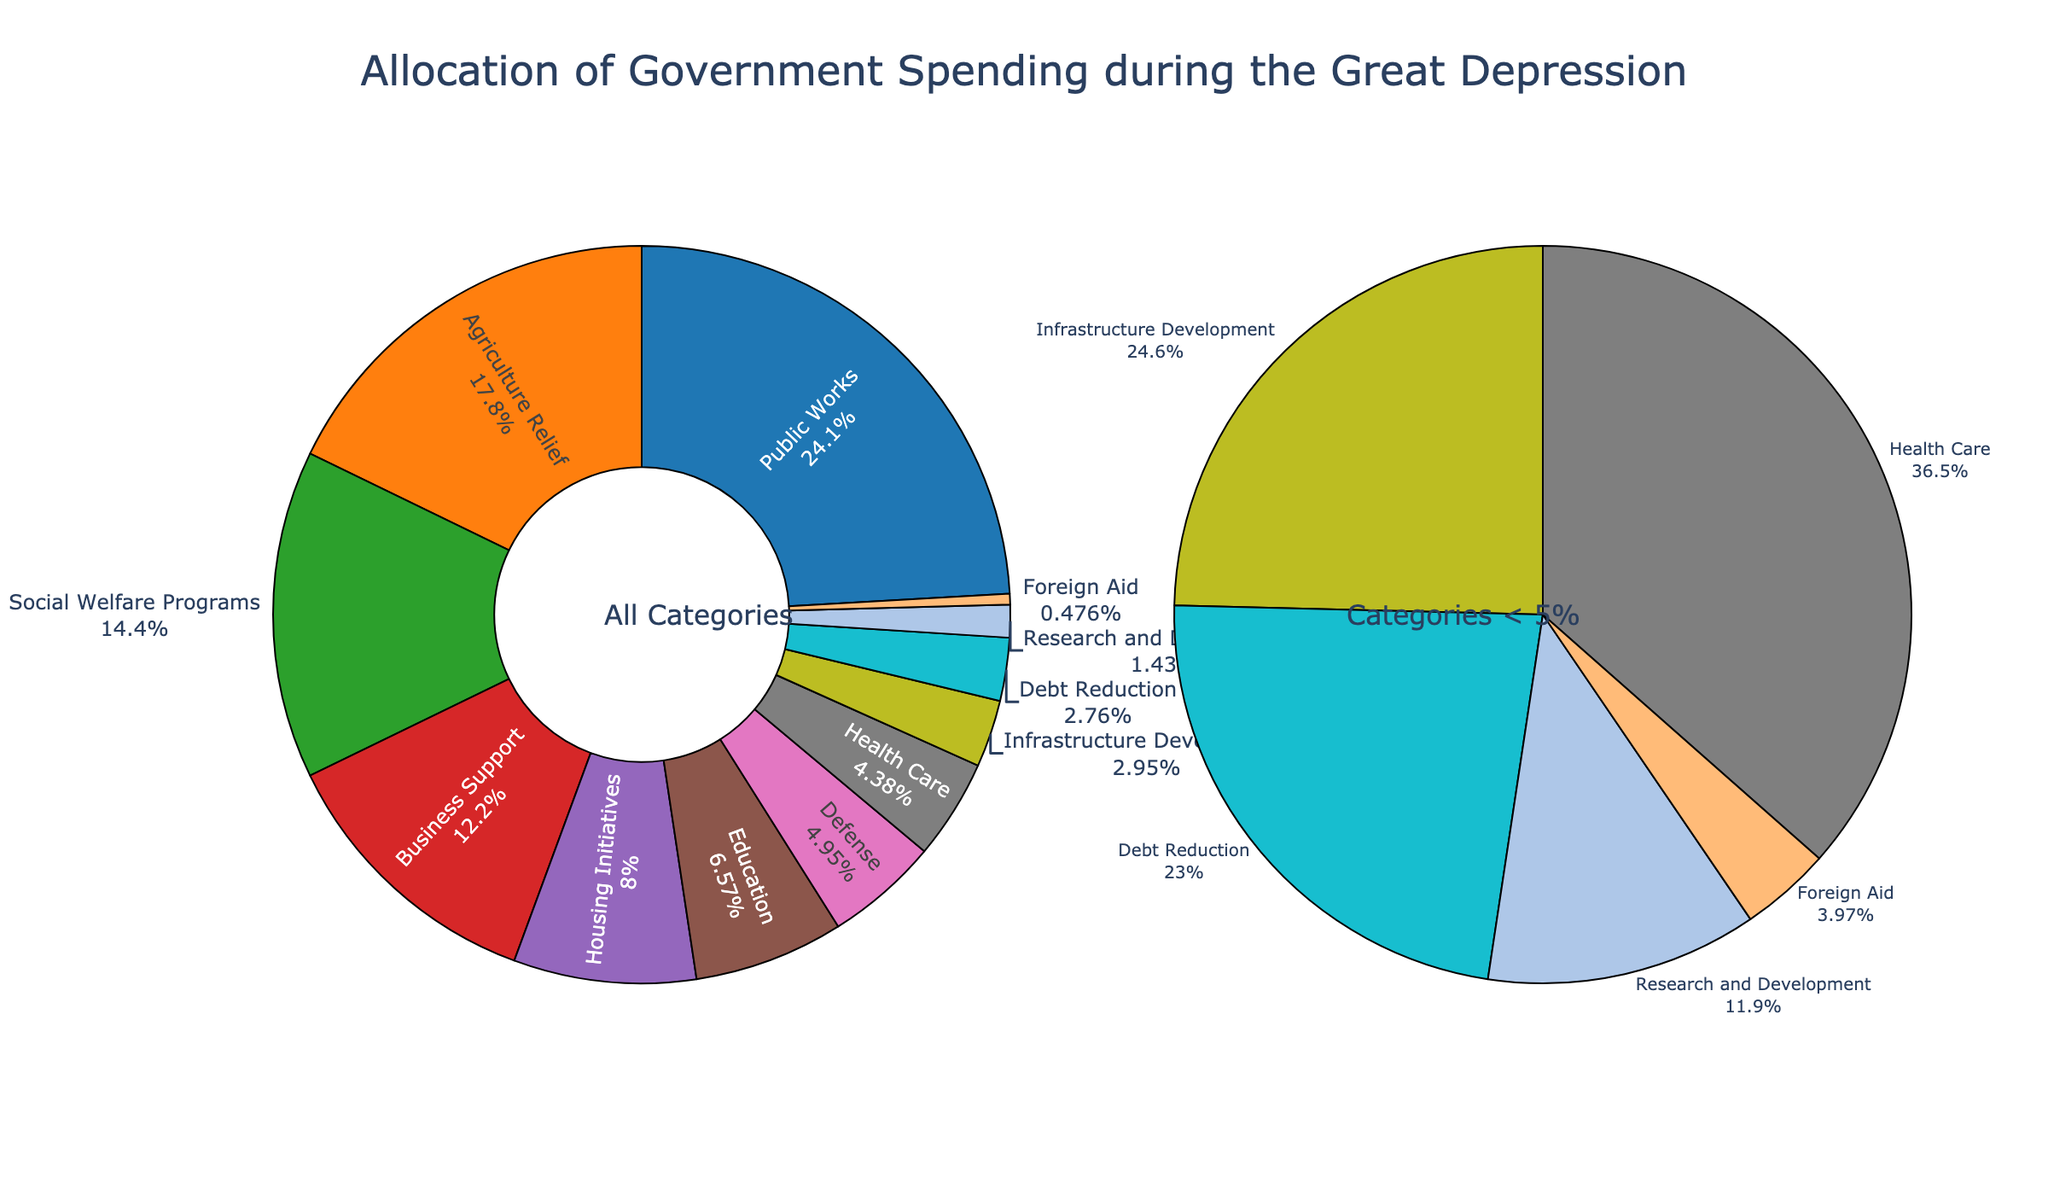What are the top three categories in terms of allocation percentage? By inspecting the main pie chart, the top three categories with the largest slices are "Public Works", "Agriculture Relief", and "Social Welfare Programs". Their respective percentages in the pie chart are 25.3%, 18.7%, and 15.1%.
Answer: Public Works, Agriculture Relief, Social Welfare Programs How much more is allocated to Public Works compared to Defense? By referring to the labels, Public Works has 25.3% while Defense has 5.2%. The difference can be calculated by subtracting the smaller percentage from the larger one: 25.3% - 5.2% = 20.1%.
Answer: 20.1% Which category has the smallest allocation and what is its percentage? By looking at the main pie chart and identifying the smallest slice or referring to the smaller pie chart for categories less than 5%, the "Foreign Aid" slice is the smallest with 0.5% allocation.
Answer: Foreign Aid, 0.5% Is the sum of allocations for Social Welfare Programs and Business Support greater than Agriculture Relief? By looking at their respective percentages in the pie chart: Social Welfare Programs (15.1%) + Business Support (12.8%) = 27.9%, while Agriculture Relief is 18.7%. Since 27.9% > 18.7%, the sum is indeed greater.
Answer: Yes Which categories have an allocation under 5%? By inspecting the smaller pie chart dedicated to categories under 5%, we see the categories labeled "Defense", "Health Care", "Infrastructure Development", "Debt Reduction", "Research and Development", and "Foreign Aid". Their respective percentages help us confirm they are all under 5%.
Answer: Defense, Health Care, Infrastructure Development, Debt Reduction, Research and Development, Foreign Aid What's the total percentage of spending on Defense, Health Care, and Infrastructure Development combined? According to the visual representation, Defense is 5.2%, Health Care is 4.6%, and Infrastructure Development is 3.1%. Adding these up: 5.2% + 4.6% + 3.1% = 12.9%.
Answer: 12.9% How does the allocation for Housing Initiatives compare to Education in terms of percentage points? Referring to their pie chart labels, Housing Initiatives have 8.4% and Education has 6.9%. The difference in percentage points is calculated by subtracting the smaller value from the larger one: 8.4% - 6.9% = 1.5%.
Answer: 1.5% What is the total allocation percentage for categories dedicated to relief (i.e., Social Welfare Programs, Agriculture Relief)? Agriculture Relief has 18.7% and Social Welfare Programs have 15.1%. Adding them together gives 18.7% + 15.1% = 33.8%.
Answer: 33.8% Which category is larger in its allocation: Debt Reduction or Research and Development? By looking at the labeled slices, Debt Reduction has an allocation of 2.9% and Research and Development has 1.5%. Since 2.9% > 1.5%, Debt Reduction's allocation is larger.
Answer: Debt Reduction 